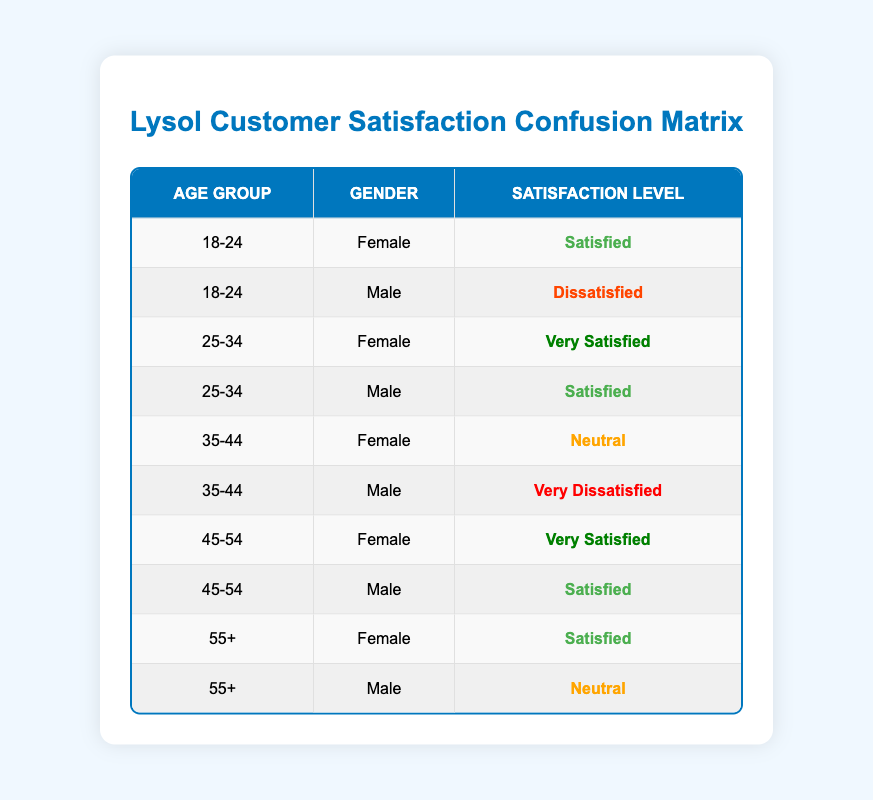What is the satisfaction level of females aged 25-34? The table shows that the satisfaction level for females aged 25-34 is "Very Satisfied."
Answer: Very Satisfied How many males are "Dissatisfied" with Lysol products? There is one male from the age group 18-24 who is "Dissatisfied," and one male from the age group 35-44 who is "Very Dissatisfied." In total, there are 2 males dissatisfied with Lysol products.
Answer: 2 Do any females aged 55+ have a "Very Satisfied" rating? In the table, the data for females aged 55+ is "Satisfied." Therefore, no females aged 55+ have a "Very Satisfied" rating.
Answer: No What is the combined number of "Very Satisfied" females across all age groups? The data shows that females aged 25-34 and 45-54 are "Very Satisfied." Therefore, there are 2 females in total who are "Very Satisfied."
Answer: 2 Is there a male in the age group 35-44 who is "Satisfied"? The table indicates that the male aged 35-44 has a satisfaction level of "Very Dissatisfied." Thus, there is no male in that age group who is "Satisfied."
Answer: No Which age group has the highest number of "Satisfied" respondents? The age groups 25-34, 45-54, and 55+ each have one "Satisfied" male and a "Very Satisfied" female or two "Satisfied" females, showing that the 45-54 age group has the highest number of satisfied respondents, with two females being "Very Satisfied."
Answer: 45-54 How many respondents are "Neutral"? The respondents that are "Neutral" include one male aged 55+ and one female aged 35-44, so there are 2 respondents in total who have a "Neutral" satisfaction level.
Answer: 2 What percentage of females across all age groups are "Satisfied" or "Very Satisfied"? The total female respondents are 5, and those who are "Satisfied" or "Very Satisfied" are 4 (1 "Very Satisfied" from ages 25-34, 1 "Very Satisfied" from ages 45-54, and 2 "Satisfied" from ages 18-24 and 55+). The percentage is calculated as (4/5) * 100 = 80%.
Answer: 80% 